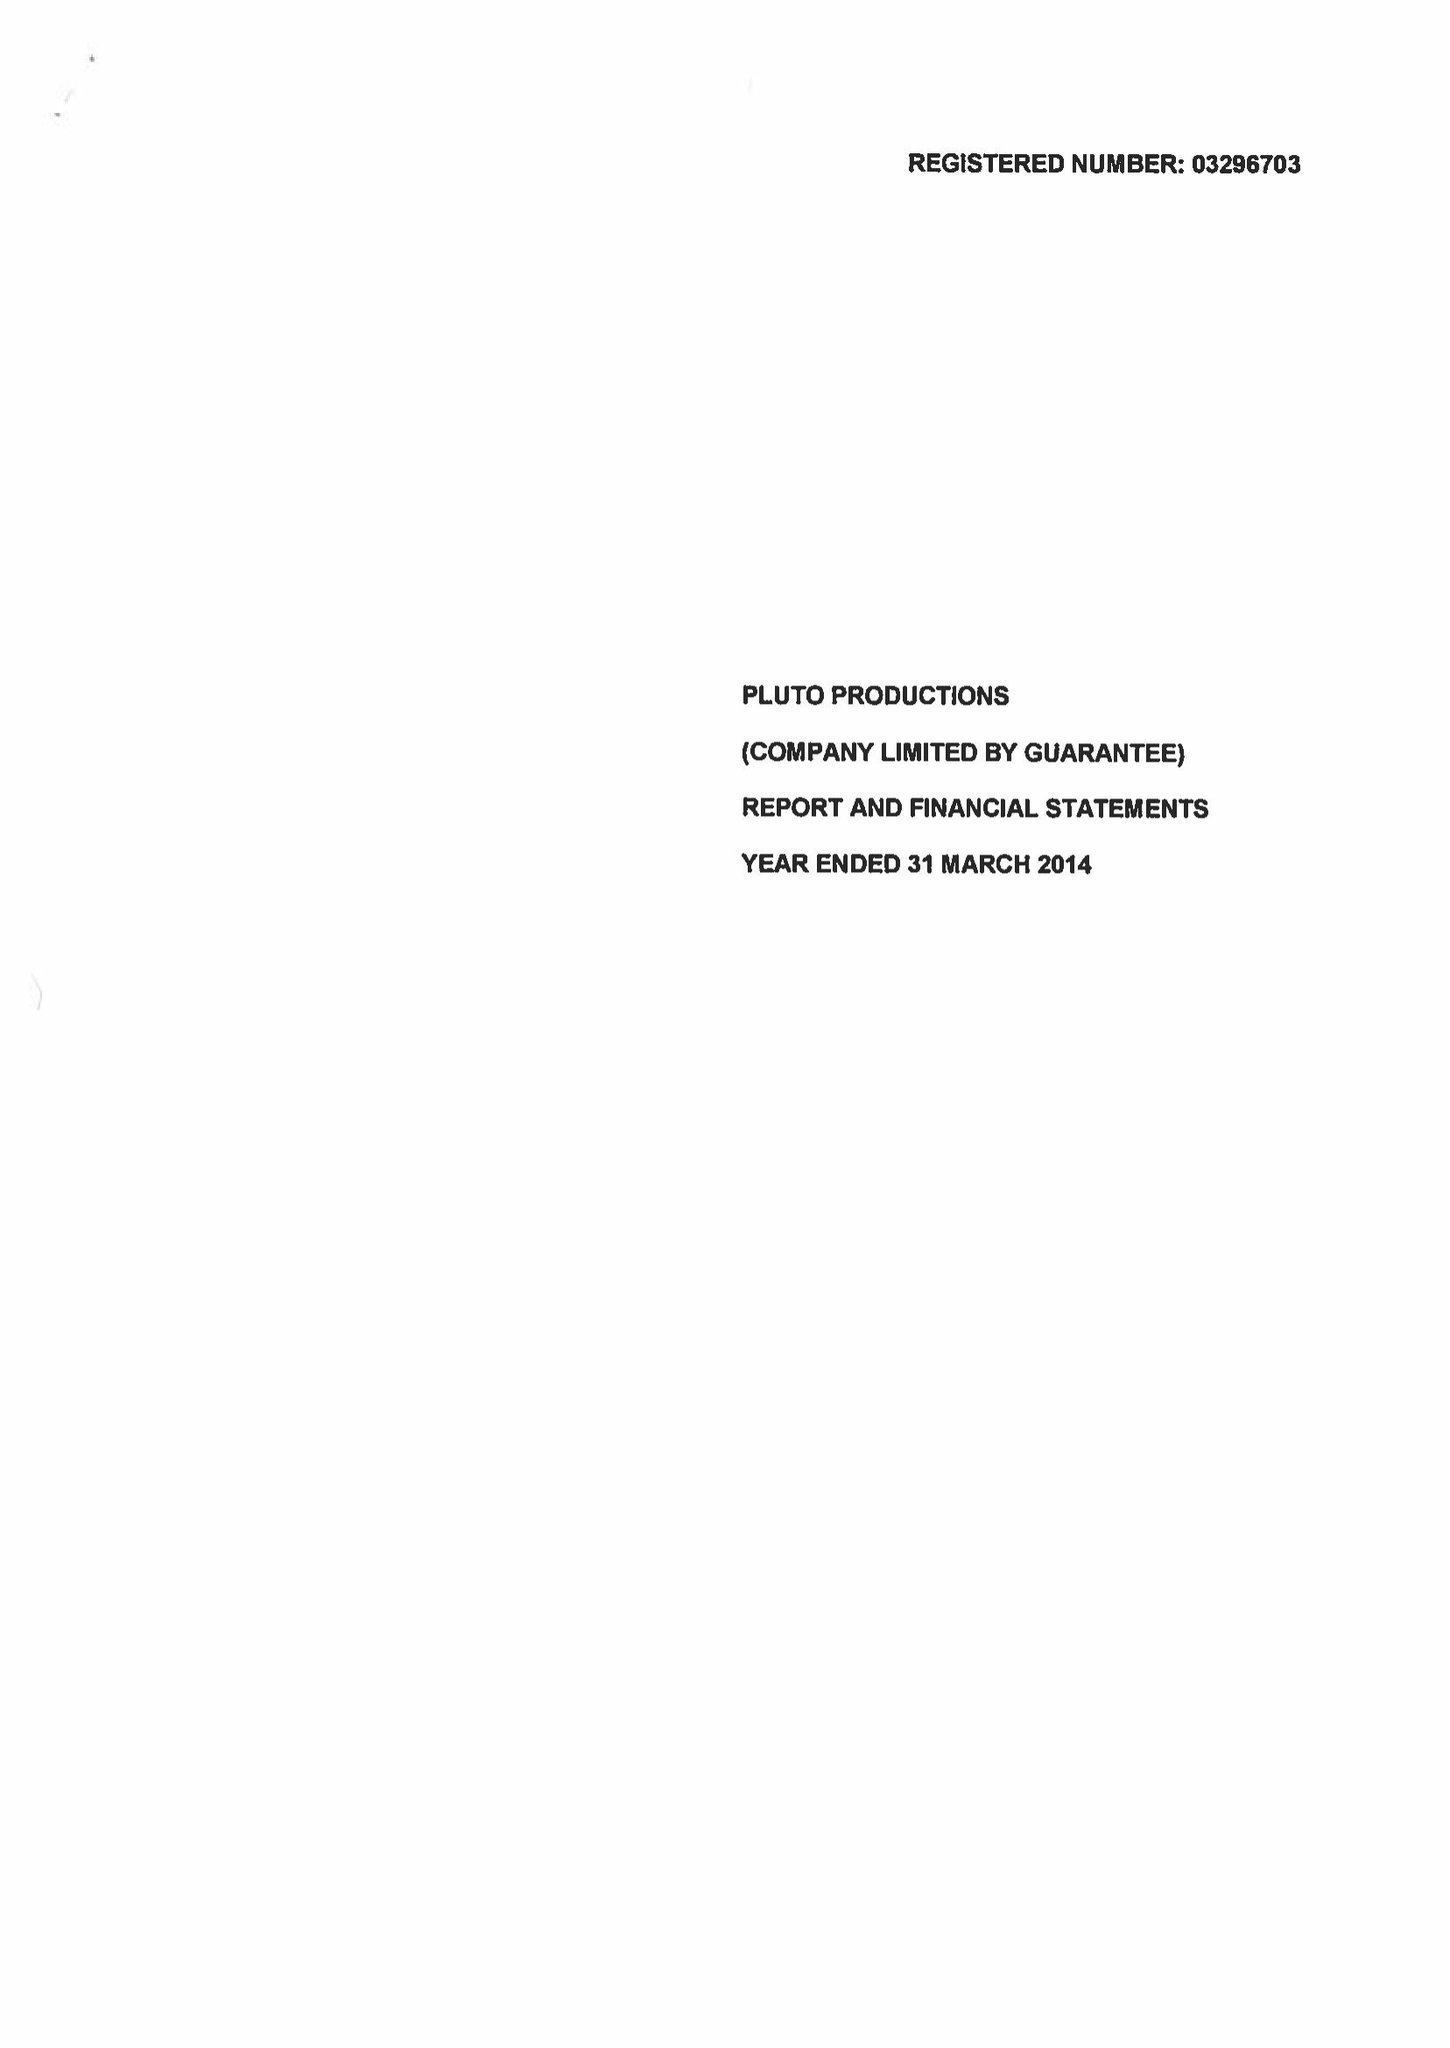What is the value for the address__post_town?
Answer the question using a single word or phrase. LEEDS 